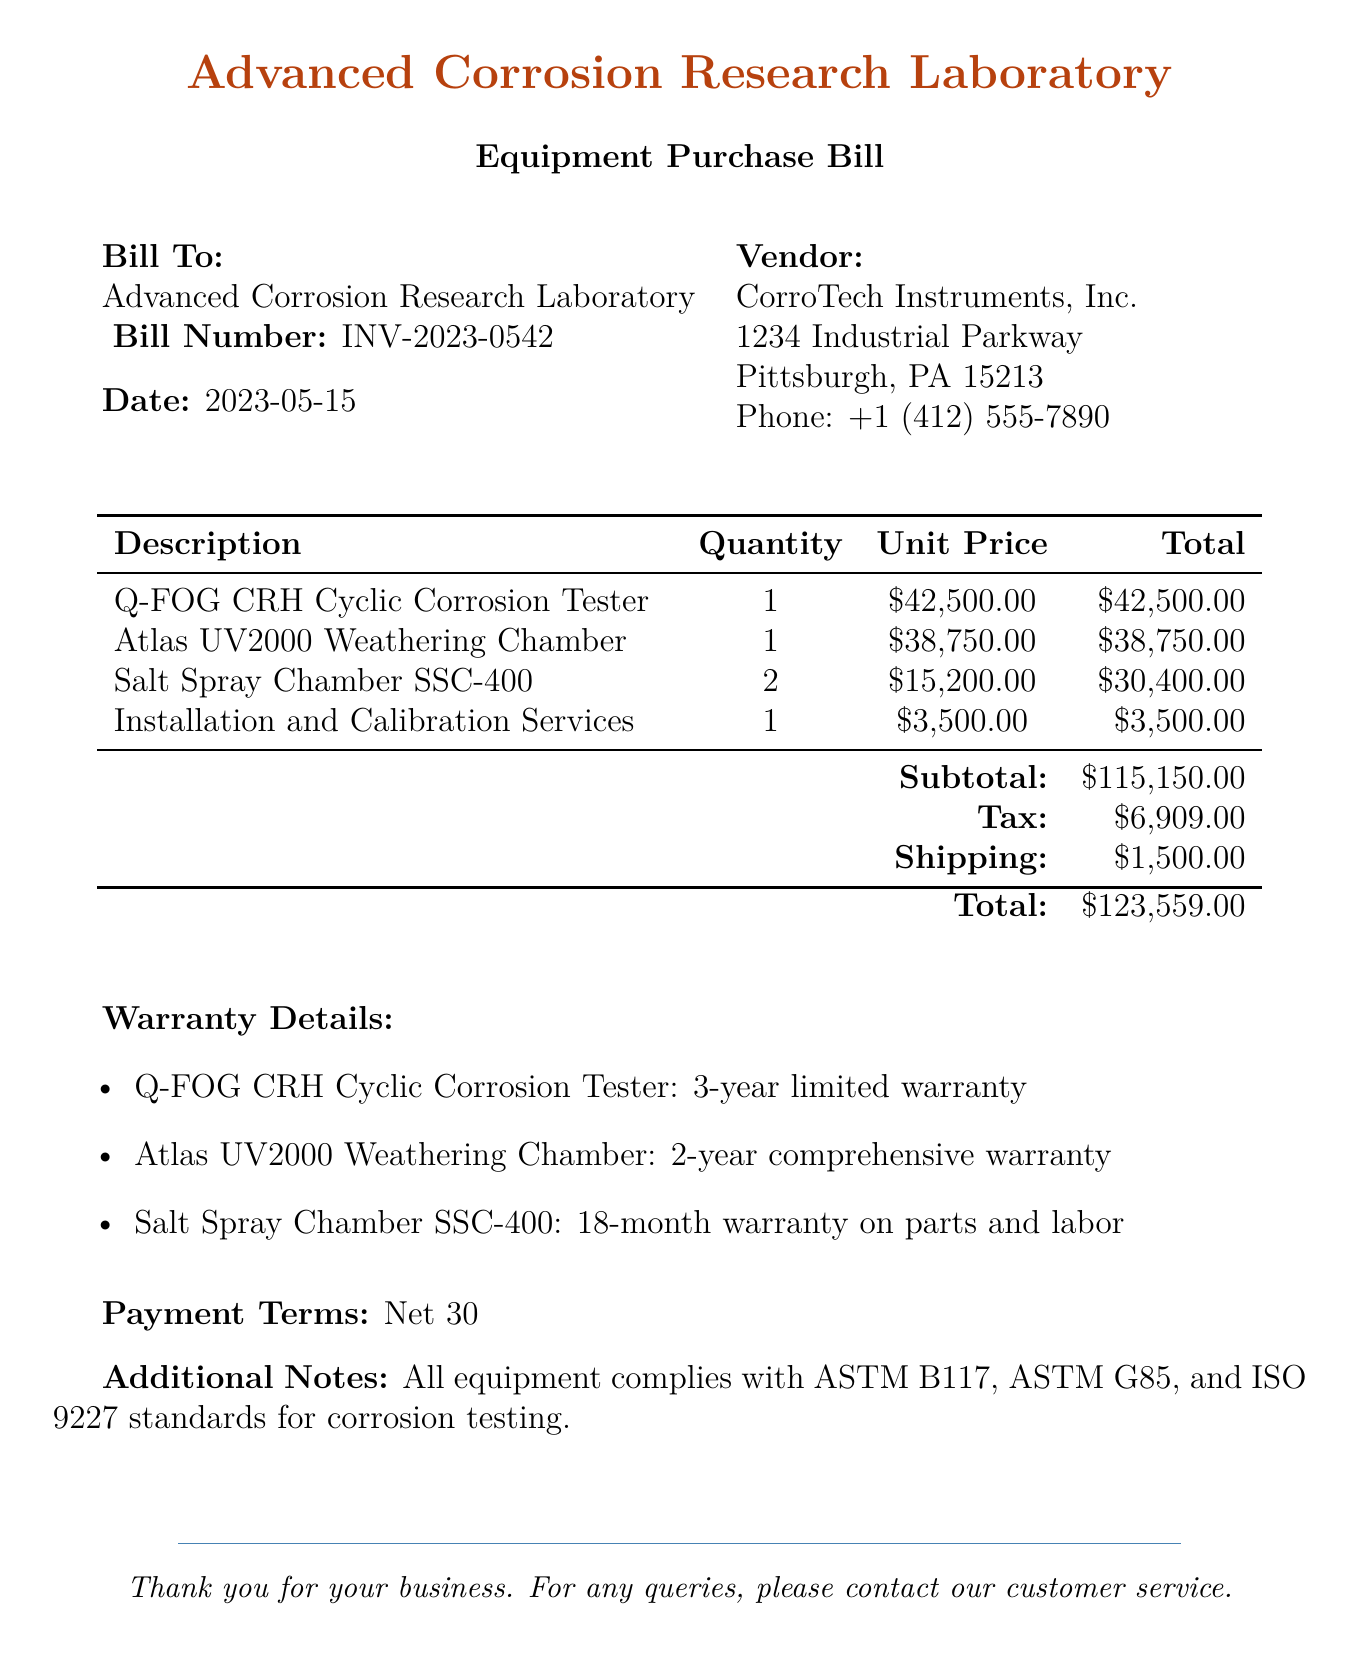What is the bill number? The bill number is listed in the document as INV-2023-0542.
Answer: INV-2023-0542 How many Salt Spray Chambers were purchased? The document states that 2 Salt Spray Chambers SSC-400 were purchased.
Answer: 2 What is the total cost before tax and shipping? The subtotal before tax and shipping is indicated as $115,150.00 in the document.
Answer: $115,150.00 What is the warranty period for the Q-FOG CRH Cyclic Corrosion Tester? The document specifies that it has a 3-year limited warranty.
Answer: 3-year limited warranty Which vendor provided the laboratory equipment? The vendor's name is CorroTech Instruments, Inc. as per the document.
Answer: CorroTech Instruments, Inc What is the payment term stipulated in the bill? The payment terms are mentioned as Net 30 in the document.
Answer: Net 30 How much was paid for Installation and Calibration Services? The cost for Installation and Calibration Services is given as $3,500.00.
Answer: $3,500.00 What is the total amount including tax and shipping? The total amount at the end of the document is listed as $123,559.00, which includes tax and shipping.
Answer: $123,559.00 What standards do the equipment comply with? The additional notes specify compliance with ASTM B117, ASTM G85, and ISO 9227 standards.
Answer: ASTM B117, ASTM G85, ISO 9227 